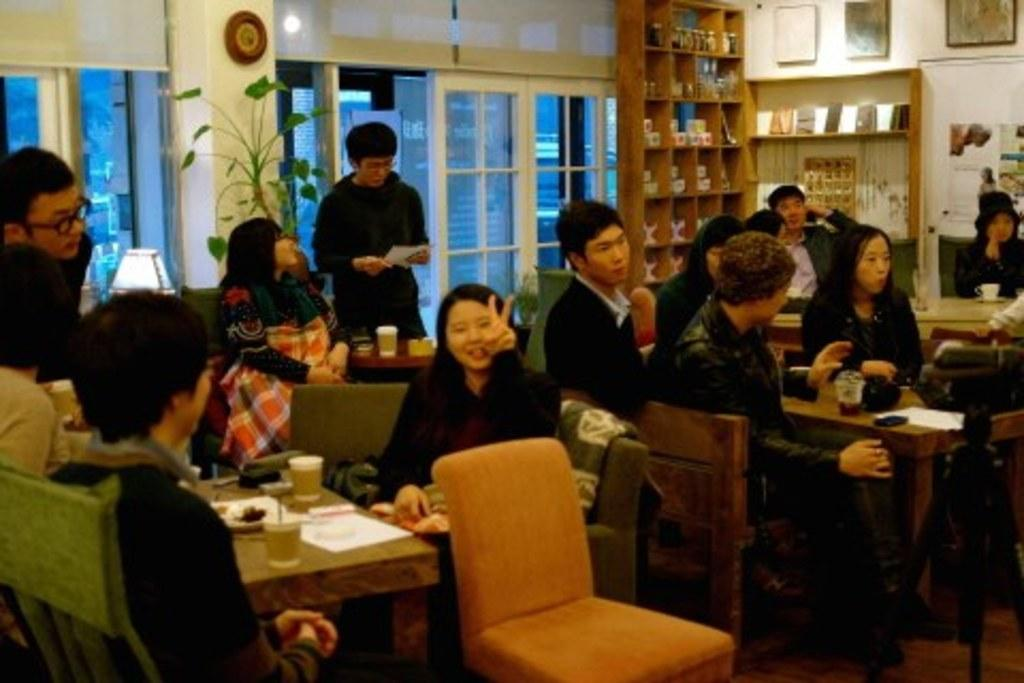What are the people in the image doing? The people in the image are sitting on chairs around a table. What can be seen near the table? There is a window beside the table and shelves with cups near the table. What type of surprise can be seen on the table in the image? There is no surprise present on the table in the image. What color is the orange on the table in the image? There is no orange present on the table in the image. 